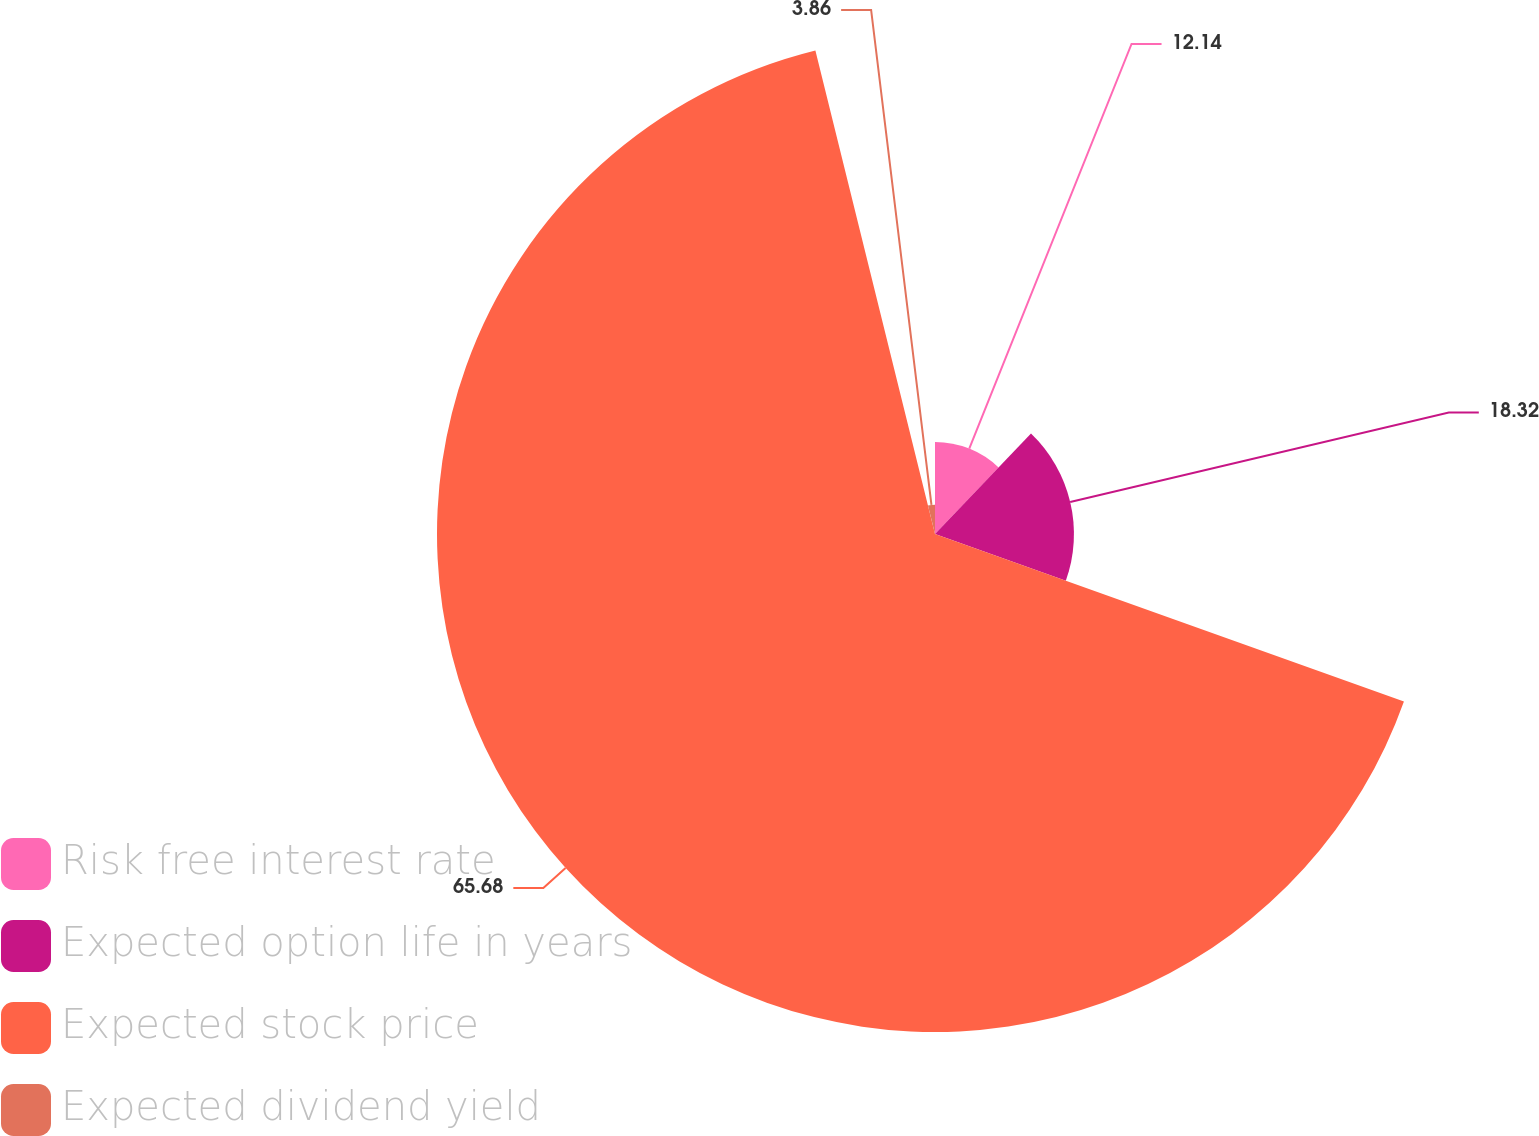Convert chart to OTSL. <chart><loc_0><loc_0><loc_500><loc_500><pie_chart><fcel>Risk free interest rate<fcel>Expected option life in years<fcel>Expected stock price<fcel>Expected dividend yield<nl><fcel>12.14%<fcel>18.32%<fcel>65.67%<fcel>3.86%<nl></chart> 